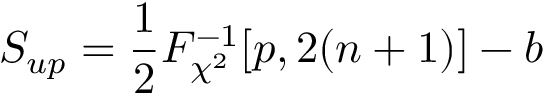Convert formula to latex. <formula><loc_0><loc_0><loc_500><loc_500>S _ { u p } = \frac { 1 } { 2 } F _ { \chi ^ { 2 } } ^ { - 1 } [ p , 2 ( n + 1 ) ] - b</formula> 